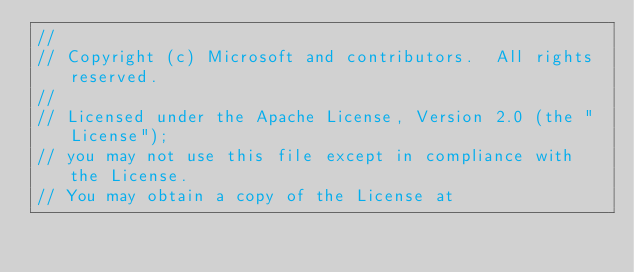Convert code to text. <code><loc_0><loc_0><loc_500><loc_500><_C#_>// 
// Copyright (c) Microsoft and contributors.  All rights reserved.
// 
// Licensed under the Apache License, Version 2.0 (the "License");
// you may not use this file except in compliance with the License.
// You may obtain a copy of the License at</code> 